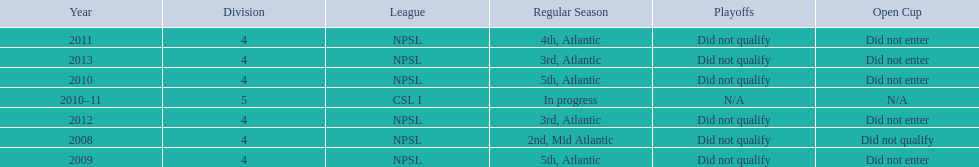Would you be able to parse every entry in this table? {'header': ['Year', 'Division', 'League', 'Regular Season', 'Playoffs', 'Open Cup'], 'rows': [['2011', '4', 'NPSL', '4th, Atlantic', 'Did not qualify', 'Did not enter'], ['2013', '4', 'NPSL', '3rd, Atlantic', 'Did not qualify', 'Did not enter'], ['2010', '4', 'NPSL', '5th, Atlantic', 'Did not qualify', 'Did not enter'], ['2010–11', '5', 'CSL I', 'In progress', 'N/A', 'N/A'], ['2012', '4', 'NPSL', '3rd, Atlantic', 'Did not qualify', 'Did not enter'], ['2008', '4', 'NPSL', '2nd, Mid Atlantic', 'Did not qualify', 'Did not qualify'], ['2009', '4', 'NPSL', '5th, Atlantic', 'Did not qualify', 'Did not enter']]} What was the last year they came in 3rd place 2013. 